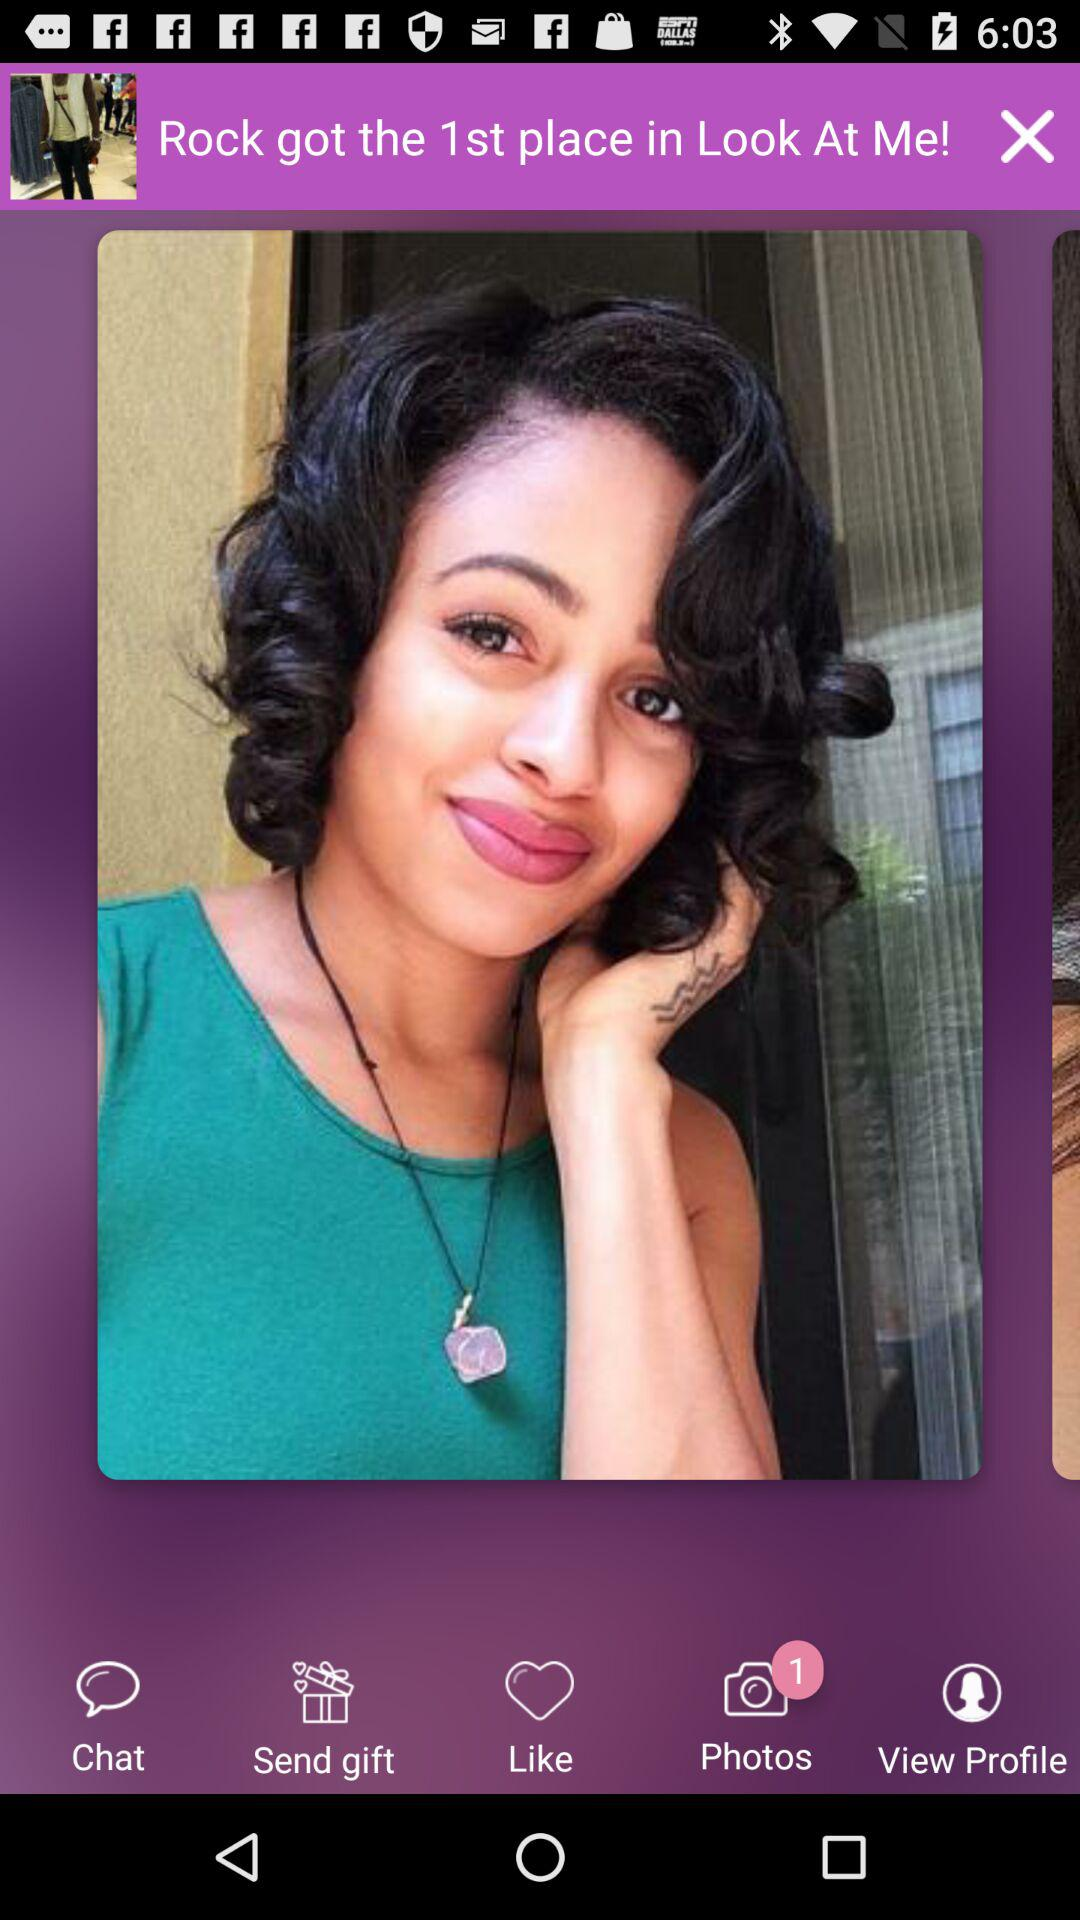How many notifications are shown in the "Photos"? There is 1 notification shown. 